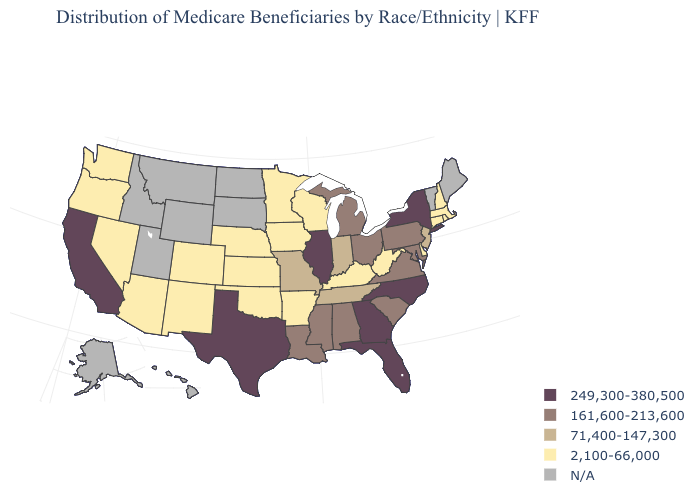What is the value of West Virginia?
Concise answer only. 2,100-66,000. What is the highest value in the West ?
Concise answer only. 249,300-380,500. Is the legend a continuous bar?
Answer briefly. No. Name the states that have a value in the range 249,300-380,500?
Write a very short answer. California, Florida, Georgia, Illinois, New York, North Carolina, Texas. What is the lowest value in states that border Maine?
Give a very brief answer. 2,100-66,000. Does the map have missing data?
Answer briefly. Yes. Which states hav the highest value in the West?
Concise answer only. California. What is the value of Maryland?
Short answer required. 161,600-213,600. What is the value of Virginia?
Concise answer only. 161,600-213,600. Name the states that have a value in the range 2,100-66,000?
Answer briefly. Arizona, Arkansas, Colorado, Connecticut, Delaware, Iowa, Kansas, Kentucky, Massachusetts, Minnesota, Nebraska, Nevada, New Hampshire, New Mexico, Oklahoma, Oregon, Rhode Island, Washington, West Virginia, Wisconsin. How many symbols are there in the legend?
Concise answer only. 5. 